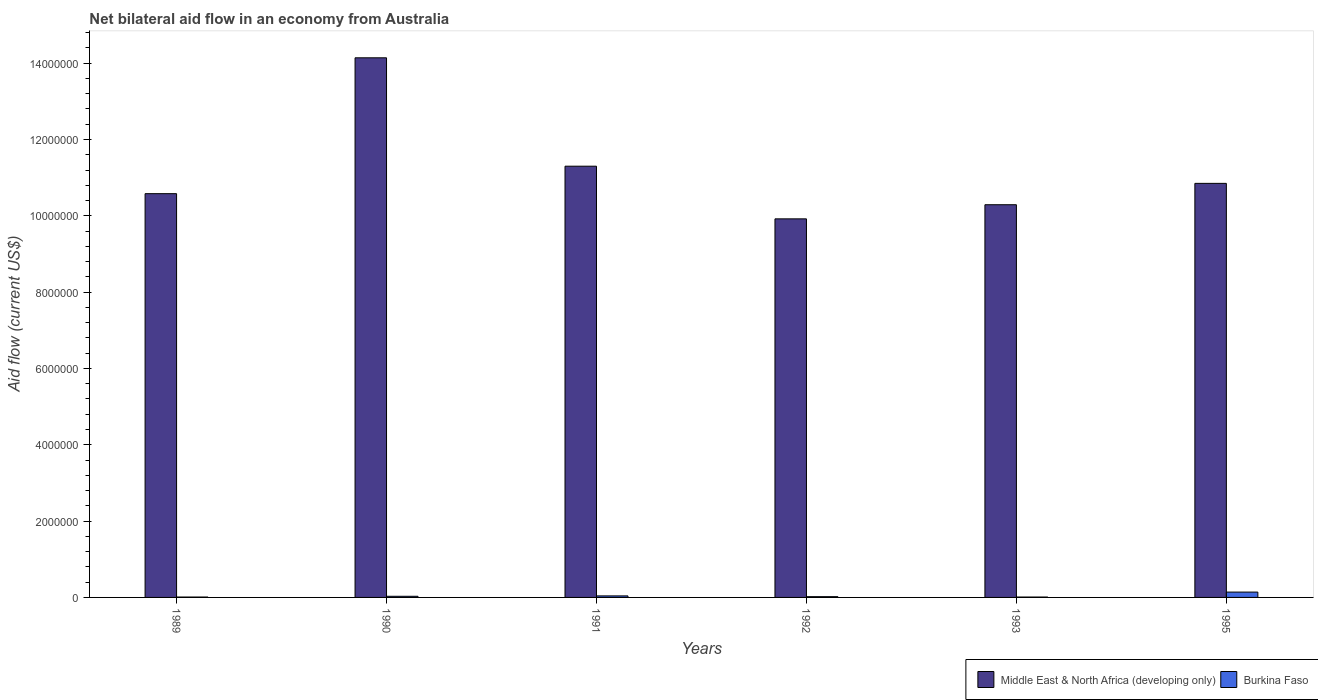How many different coloured bars are there?
Ensure brevity in your answer.  2. Are the number of bars per tick equal to the number of legend labels?
Your answer should be very brief. Yes. How many bars are there on the 3rd tick from the right?
Your response must be concise. 2. In how many cases, is the number of bars for a given year not equal to the number of legend labels?
Ensure brevity in your answer.  0. What is the net bilateral aid flow in Middle East & North Africa (developing only) in 1995?
Provide a succinct answer. 1.08e+07. Across all years, what is the maximum net bilateral aid flow in Middle East & North Africa (developing only)?
Your answer should be very brief. 1.41e+07. Across all years, what is the minimum net bilateral aid flow in Middle East & North Africa (developing only)?
Provide a short and direct response. 9.92e+06. In which year was the net bilateral aid flow in Middle East & North Africa (developing only) maximum?
Offer a terse response. 1990. What is the total net bilateral aid flow in Burkina Faso in the graph?
Your answer should be compact. 2.50e+05. What is the difference between the net bilateral aid flow in Middle East & North Africa (developing only) in 1989 and that in 1990?
Your response must be concise. -3.56e+06. What is the difference between the net bilateral aid flow in Middle East & North Africa (developing only) in 1992 and the net bilateral aid flow in Burkina Faso in 1995?
Your response must be concise. 9.78e+06. What is the average net bilateral aid flow in Middle East & North Africa (developing only) per year?
Keep it short and to the point. 1.12e+07. In the year 1995, what is the difference between the net bilateral aid flow in Middle East & North Africa (developing only) and net bilateral aid flow in Burkina Faso?
Give a very brief answer. 1.07e+07. In how many years, is the net bilateral aid flow in Middle East & North Africa (developing only) greater than 6400000 US$?
Make the answer very short. 6. What is the ratio of the net bilateral aid flow in Middle East & North Africa (developing only) in 1992 to that in 1993?
Offer a very short reply. 0.96. Is the net bilateral aid flow in Middle East & North Africa (developing only) in 1991 less than that in 1993?
Your answer should be very brief. No. Is the difference between the net bilateral aid flow in Middle East & North Africa (developing only) in 1991 and 1995 greater than the difference between the net bilateral aid flow in Burkina Faso in 1991 and 1995?
Your response must be concise. Yes. What is the difference between the highest and the second highest net bilateral aid flow in Middle East & North Africa (developing only)?
Give a very brief answer. 2.84e+06. What is the difference between the highest and the lowest net bilateral aid flow in Burkina Faso?
Ensure brevity in your answer.  1.30e+05. Is the sum of the net bilateral aid flow in Middle East & North Africa (developing only) in 1991 and 1995 greater than the maximum net bilateral aid flow in Burkina Faso across all years?
Your answer should be compact. Yes. What does the 2nd bar from the left in 1992 represents?
Offer a very short reply. Burkina Faso. What does the 2nd bar from the right in 1991 represents?
Your answer should be compact. Middle East & North Africa (developing only). How many bars are there?
Offer a very short reply. 12. Are all the bars in the graph horizontal?
Give a very brief answer. No. How many years are there in the graph?
Make the answer very short. 6. Are the values on the major ticks of Y-axis written in scientific E-notation?
Offer a terse response. No. Does the graph contain grids?
Make the answer very short. No. How are the legend labels stacked?
Offer a terse response. Horizontal. What is the title of the graph?
Your answer should be compact. Net bilateral aid flow in an economy from Australia. Does "Malaysia" appear as one of the legend labels in the graph?
Ensure brevity in your answer.  No. What is the Aid flow (current US$) of Middle East & North Africa (developing only) in 1989?
Keep it short and to the point. 1.06e+07. What is the Aid flow (current US$) in Middle East & North Africa (developing only) in 1990?
Give a very brief answer. 1.41e+07. What is the Aid flow (current US$) in Middle East & North Africa (developing only) in 1991?
Make the answer very short. 1.13e+07. What is the Aid flow (current US$) of Middle East & North Africa (developing only) in 1992?
Keep it short and to the point. 9.92e+06. What is the Aid flow (current US$) in Burkina Faso in 1992?
Offer a terse response. 2.00e+04. What is the Aid flow (current US$) in Middle East & North Africa (developing only) in 1993?
Give a very brief answer. 1.03e+07. What is the Aid flow (current US$) of Burkina Faso in 1993?
Your response must be concise. 10000. What is the Aid flow (current US$) of Middle East & North Africa (developing only) in 1995?
Your response must be concise. 1.08e+07. Across all years, what is the maximum Aid flow (current US$) in Middle East & North Africa (developing only)?
Your answer should be compact. 1.41e+07. Across all years, what is the minimum Aid flow (current US$) in Middle East & North Africa (developing only)?
Your answer should be compact. 9.92e+06. What is the total Aid flow (current US$) of Middle East & North Africa (developing only) in the graph?
Keep it short and to the point. 6.71e+07. What is the total Aid flow (current US$) in Burkina Faso in the graph?
Offer a terse response. 2.50e+05. What is the difference between the Aid flow (current US$) in Middle East & North Africa (developing only) in 1989 and that in 1990?
Ensure brevity in your answer.  -3.56e+06. What is the difference between the Aid flow (current US$) of Burkina Faso in 1989 and that in 1990?
Your answer should be compact. -2.00e+04. What is the difference between the Aid flow (current US$) in Middle East & North Africa (developing only) in 1989 and that in 1991?
Offer a terse response. -7.20e+05. What is the difference between the Aid flow (current US$) of Middle East & North Africa (developing only) in 1989 and that in 1992?
Provide a short and direct response. 6.60e+05. What is the difference between the Aid flow (current US$) of Burkina Faso in 1989 and that in 1995?
Your answer should be very brief. -1.30e+05. What is the difference between the Aid flow (current US$) in Middle East & North Africa (developing only) in 1990 and that in 1991?
Your response must be concise. 2.84e+06. What is the difference between the Aid flow (current US$) of Burkina Faso in 1990 and that in 1991?
Give a very brief answer. -10000. What is the difference between the Aid flow (current US$) in Middle East & North Africa (developing only) in 1990 and that in 1992?
Provide a succinct answer. 4.22e+06. What is the difference between the Aid flow (current US$) in Burkina Faso in 1990 and that in 1992?
Your answer should be compact. 10000. What is the difference between the Aid flow (current US$) in Middle East & North Africa (developing only) in 1990 and that in 1993?
Give a very brief answer. 3.85e+06. What is the difference between the Aid flow (current US$) in Middle East & North Africa (developing only) in 1990 and that in 1995?
Make the answer very short. 3.29e+06. What is the difference between the Aid flow (current US$) of Burkina Faso in 1990 and that in 1995?
Provide a succinct answer. -1.10e+05. What is the difference between the Aid flow (current US$) in Middle East & North Africa (developing only) in 1991 and that in 1992?
Your answer should be compact. 1.38e+06. What is the difference between the Aid flow (current US$) of Middle East & North Africa (developing only) in 1991 and that in 1993?
Offer a terse response. 1.01e+06. What is the difference between the Aid flow (current US$) in Burkina Faso in 1991 and that in 1993?
Your response must be concise. 3.00e+04. What is the difference between the Aid flow (current US$) of Burkina Faso in 1991 and that in 1995?
Make the answer very short. -1.00e+05. What is the difference between the Aid flow (current US$) in Middle East & North Africa (developing only) in 1992 and that in 1993?
Provide a short and direct response. -3.70e+05. What is the difference between the Aid flow (current US$) in Middle East & North Africa (developing only) in 1992 and that in 1995?
Your response must be concise. -9.30e+05. What is the difference between the Aid flow (current US$) of Middle East & North Africa (developing only) in 1993 and that in 1995?
Your answer should be compact. -5.60e+05. What is the difference between the Aid flow (current US$) of Burkina Faso in 1993 and that in 1995?
Your response must be concise. -1.30e+05. What is the difference between the Aid flow (current US$) in Middle East & North Africa (developing only) in 1989 and the Aid flow (current US$) in Burkina Faso in 1990?
Ensure brevity in your answer.  1.06e+07. What is the difference between the Aid flow (current US$) of Middle East & North Africa (developing only) in 1989 and the Aid flow (current US$) of Burkina Faso in 1991?
Your answer should be compact. 1.05e+07. What is the difference between the Aid flow (current US$) in Middle East & North Africa (developing only) in 1989 and the Aid flow (current US$) in Burkina Faso in 1992?
Offer a very short reply. 1.06e+07. What is the difference between the Aid flow (current US$) of Middle East & North Africa (developing only) in 1989 and the Aid flow (current US$) of Burkina Faso in 1993?
Your response must be concise. 1.06e+07. What is the difference between the Aid flow (current US$) of Middle East & North Africa (developing only) in 1989 and the Aid flow (current US$) of Burkina Faso in 1995?
Provide a succinct answer. 1.04e+07. What is the difference between the Aid flow (current US$) in Middle East & North Africa (developing only) in 1990 and the Aid flow (current US$) in Burkina Faso in 1991?
Your response must be concise. 1.41e+07. What is the difference between the Aid flow (current US$) in Middle East & North Africa (developing only) in 1990 and the Aid flow (current US$) in Burkina Faso in 1992?
Provide a short and direct response. 1.41e+07. What is the difference between the Aid flow (current US$) of Middle East & North Africa (developing only) in 1990 and the Aid flow (current US$) of Burkina Faso in 1993?
Your answer should be very brief. 1.41e+07. What is the difference between the Aid flow (current US$) in Middle East & North Africa (developing only) in 1990 and the Aid flow (current US$) in Burkina Faso in 1995?
Your answer should be compact. 1.40e+07. What is the difference between the Aid flow (current US$) in Middle East & North Africa (developing only) in 1991 and the Aid flow (current US$) in Burkina Faso in 1992?
Your answer should be very brief. 1.13e+07. What is the difference between the Aid flow (current US$) of Middle East & North Africa (developing only) in 1991 and the Aid flow (current US$) of Burkina Faso in 1993?
Keep it short and to the point. 1.13e+07. What is the difference between the Aid flow (current US$) in Middle East & North Africa (developing only) in 1991 and the Aid flow (current US$) in Burkina Faso in 1995?
Make the answer very short. 1.12e+07. What is the difference between the Aid flow (current US$) in Middle East & North Africa (developing only) in 1992 and the Aid flow (current US$) in Burkina Faso in 1993?
Make the answer very short. 9.91e+06. What is the difference between the Aid flow (current US$) of Middle East & North Africa (developing only) in 1992 and the Aid flow (current US$) of Burkina Faso in 1995?
Make the answer very short. 9.78e+06. What is the difference between the Aid flow (current US$) in Middle East & North Africa (developing only) in 1993 and the Aid flow (current US$) in Burkina Faso in 1995?
Offer a very short reply. 1.02e+07. What is the average Aid flow (current US$) of Middle East & North Africa (developing only) per year?
Ensure brevity in your answer.  1.12e+07. What is the average Aid flow (current US$) of Burkina Faso per year?
Provide a short and direct response. 4.17e+04. In the year 1989, what is the difference between the Aid flow (current US$) in Middle East & North Africa (developing only) and Aid flow (current US$) in Burkina Faso?
Offer a very short reply. 1.06e+07. In the year 1990, what is the difference between the Aid flow (current US$) of Middle East & North Africa (developing only) and Aid flow (current US$) of Burkina Faso?
Offer a terse response. 1.41e+07. In the year 1991, what is the difference between the Aid flow (current US$) in Middle East & North Africa (developing only) and Aid flow (current US$) in Burkina Faso?
Make the answer very short. 1.13e+07. In the year 1992, what is the difference between the Aid flow (current US$) of Middle East & North Africa (developing only) and Aid flow (current US$) of Burkina Faso?
Ensure brevity in your answer.  9.90e+06. In the year 1993, what is the difference between the Aid flow (current US$) in Middle East & North Africa (developing only) and Aid flow (current US$) in Burkina Faso?
Provide a succinct answer. 1.03e+07. In the year 1995, what is the difference between the Aid flow (current US$) in Middle East & North Africa (developing only) and Aid flow (current US$) in Burkina Faso?
Your answer should be very brief. 1.07e+07. What is the ratio of the Aid flow (current US$) in Middle East & North Africa (developing only) in 1989 to that in 1990?
Offer a terse response. 0.75. What is the ratio of the Aid flow (current US$) of Middle East & North Africa (developing only) in 1989 to that in 1991?
Your response must be concise. 0.94. What is the ratio of the Aid flow (current US$) of Middle East & North Africa (developing only) in 1989 to that in 1992?
Keep it short and to the point. 1.07. What is the ratio of the Aid flow (current US$) of Burkina Faso in 1989 to that in 1992?
Offer a very short reply. 0.5. What is the ratio of the Aid flow (current US$) in Middle East & North Africa (developing only) in 1989 to that in 1993?
Offer a very short reply. 1.03. What is the ratio of the Aid flow (current US$) of Middle East & North Africa (developing only) in 1989 to that in 1995?
Your answer should be very brief. 0.98. What is the ratio of the Aid flow (current US$) of Burkina Faso in 1989 to that in 1995?
Provide a short and direct response. 0.07. What is the ratio of the Aid flow (current US$) in Middle East & North Africa (developing only) in 1990 to that in 1991?
Offer a very short reply. 1.25. What is the ratio of the Aid flow (current US$) of Middle East & North Africa (developing only) in 1990 to that in 1992?
Your response must be concise. 1.43. What is the ratio of the Aid flow (current US$) of Middle East & North Africa (developing only) in 1990 to that in 1993?
Keep it short and to the point. 1.37. What is the ratio of the Aid flow (current US$) of Middle East & North Africa (developing only) in 1990 to that in 1995?
Your answer should be very brief. 1.3. What is the ratio of the Aid flow (current US$) in Burkina Faso in 1990 to that in 1995?
Offer a terse response. 0.21. What is the ratio of the Aid flow (current US$) of Middle East & North Africa (developing only) in 1991 to that in 1992?
Your answer should be very brief. 1.14. What is the ratio of the Aid flow (current US$) in Burkina Faso in 1991 to that in 1992?
Provide a succinct answer. 2. What is the ratio of the Aid flow (current US$) in Middle East & North Africa (developing only) in 1991 to that in 1993?
Your answer should be very brief. 1.1. What is the ratio of the Aid flow (current US$) in Middle East & North Africa (developing only) in 1991 to that in 1995?
Provide a succinct answer. 1.04. What is the ratio of the Aid flow (current US$) of Burkina Faso in 1991 to that in 1995?
Your response must be concise. 0.29. What is the ratio of the Aid flow (current US$) in Burkina Faso in 1992 to that in 1993?
Provide a short and direct response. 2. What is the ratio of the Aid flow (current US$) in Middle East & North Africa (developing only) in 1992 to that in 1995?
Provide a succinct answer. 0.91. What is the ratio of the Aid flow (current US$) in Burkina Faso in 1992 to that in 1995?
Ensure brevity in your answer.  0.14. What is the ratio of the Aid flow (current US$) in Middle East & North Africa (developing only) in 1993 to that in 1995?
Your response must be concise. 0.95. What is the ratio of the Aid flow (current US$) in Burkina Faso in 1993 to that in 1995?
Your answer should be compact. 0.07. What is the difference between the highest and the second highest Aid flow (current US$) of Middle East & North Africa (developing only)?
Keep it short and to the point. 2.84e+06. What is the difference between the highest and the lowest Aid flow (current US$) in Middle East & North Africa (developing only)?
Provide a succinct answer. 4.22e+06. 